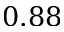<formula> <loc_0><loc_0><loc_500><loc_500>0 . 8 8</formula> 